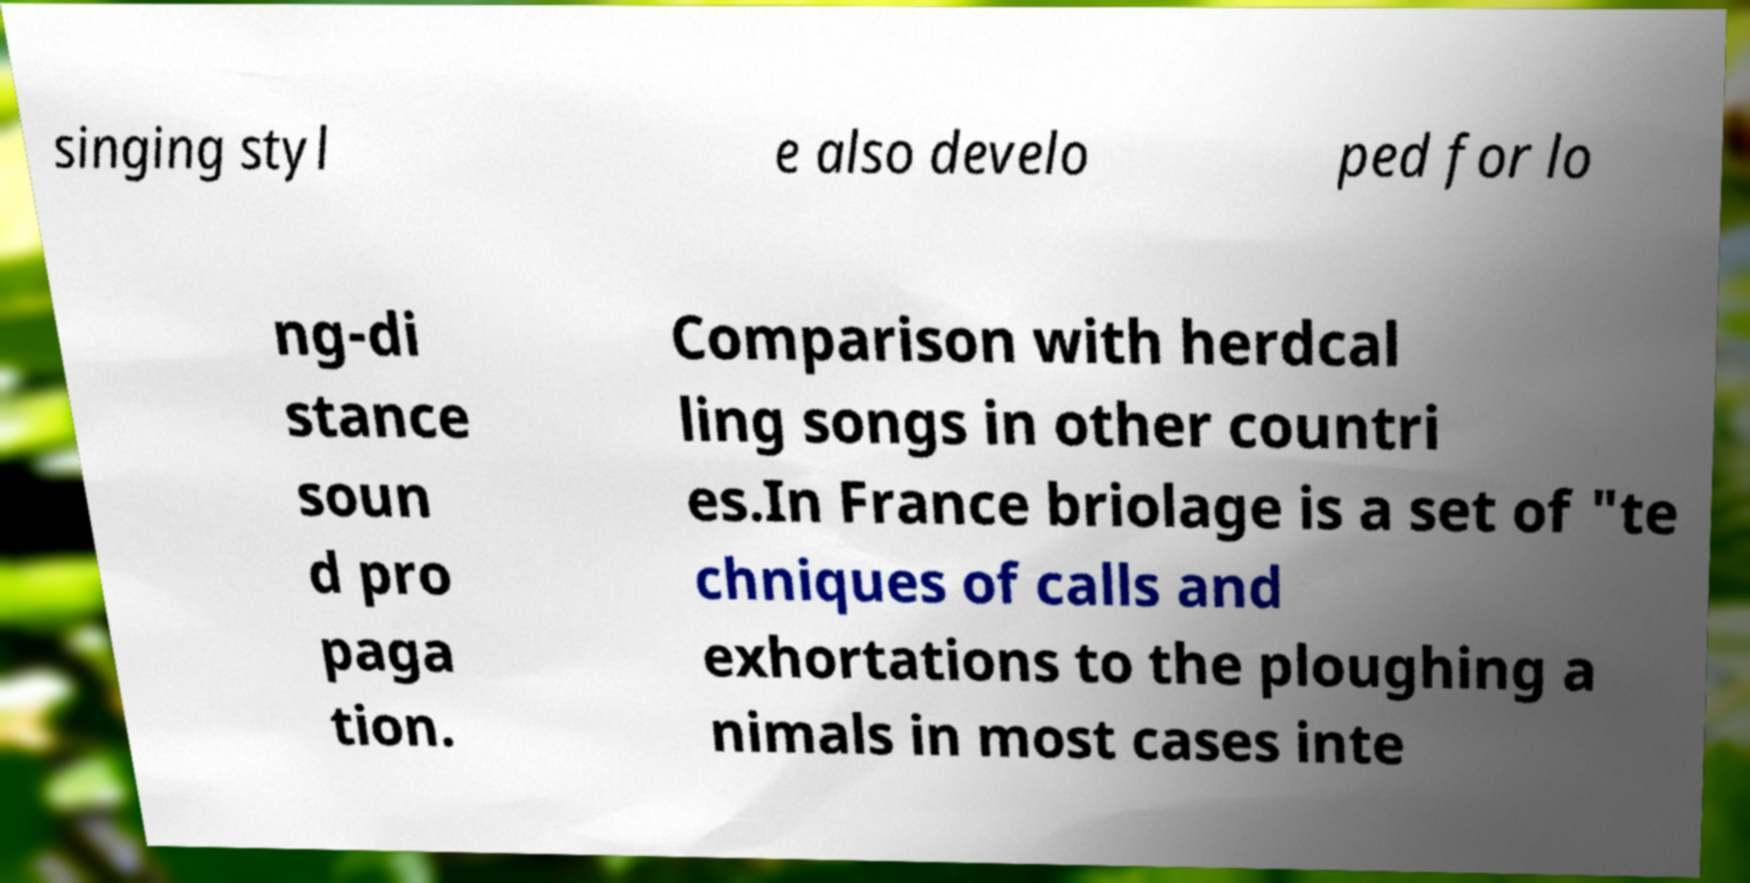I need the written content from this picture converted into text. Can you do that? singing styl e also develo ped for lo ng-di stance soun d pro paga tion. Comparison with herdcal ling songs in other countri es.In France briolage is a set of "te chniques of calls and exhortations to the ploughing a nimals in most cases inte 